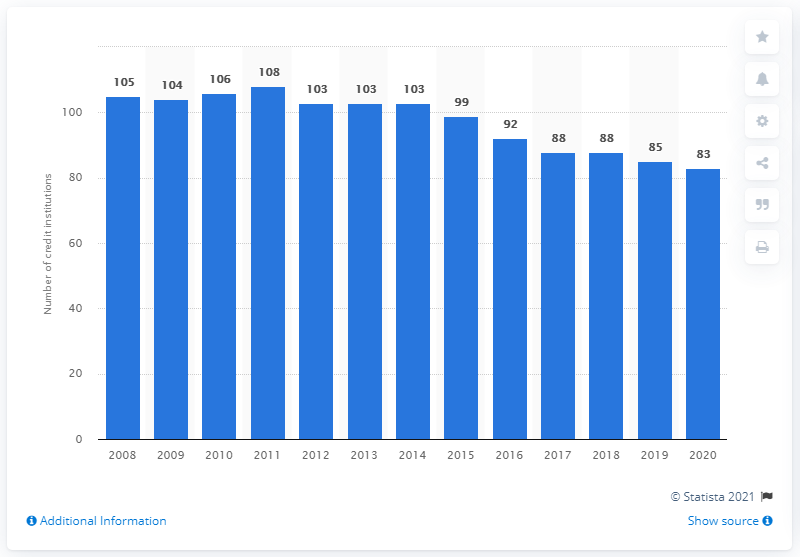Point out several critical features in this image. As of December 2020, there were 83 credit institutes operating in Belgium. 